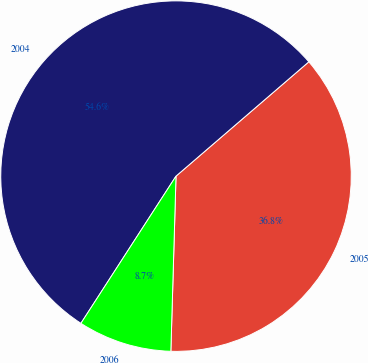Convert chart to OTSL. <chart><loc_0><loc_0><loc_500><loc_500><pie_chart><fcel>2005<fcel>2004<fcel>2006<nl><fcel>36.78%<fcel>54.56%<fcel>8.66%<nl></chart> 